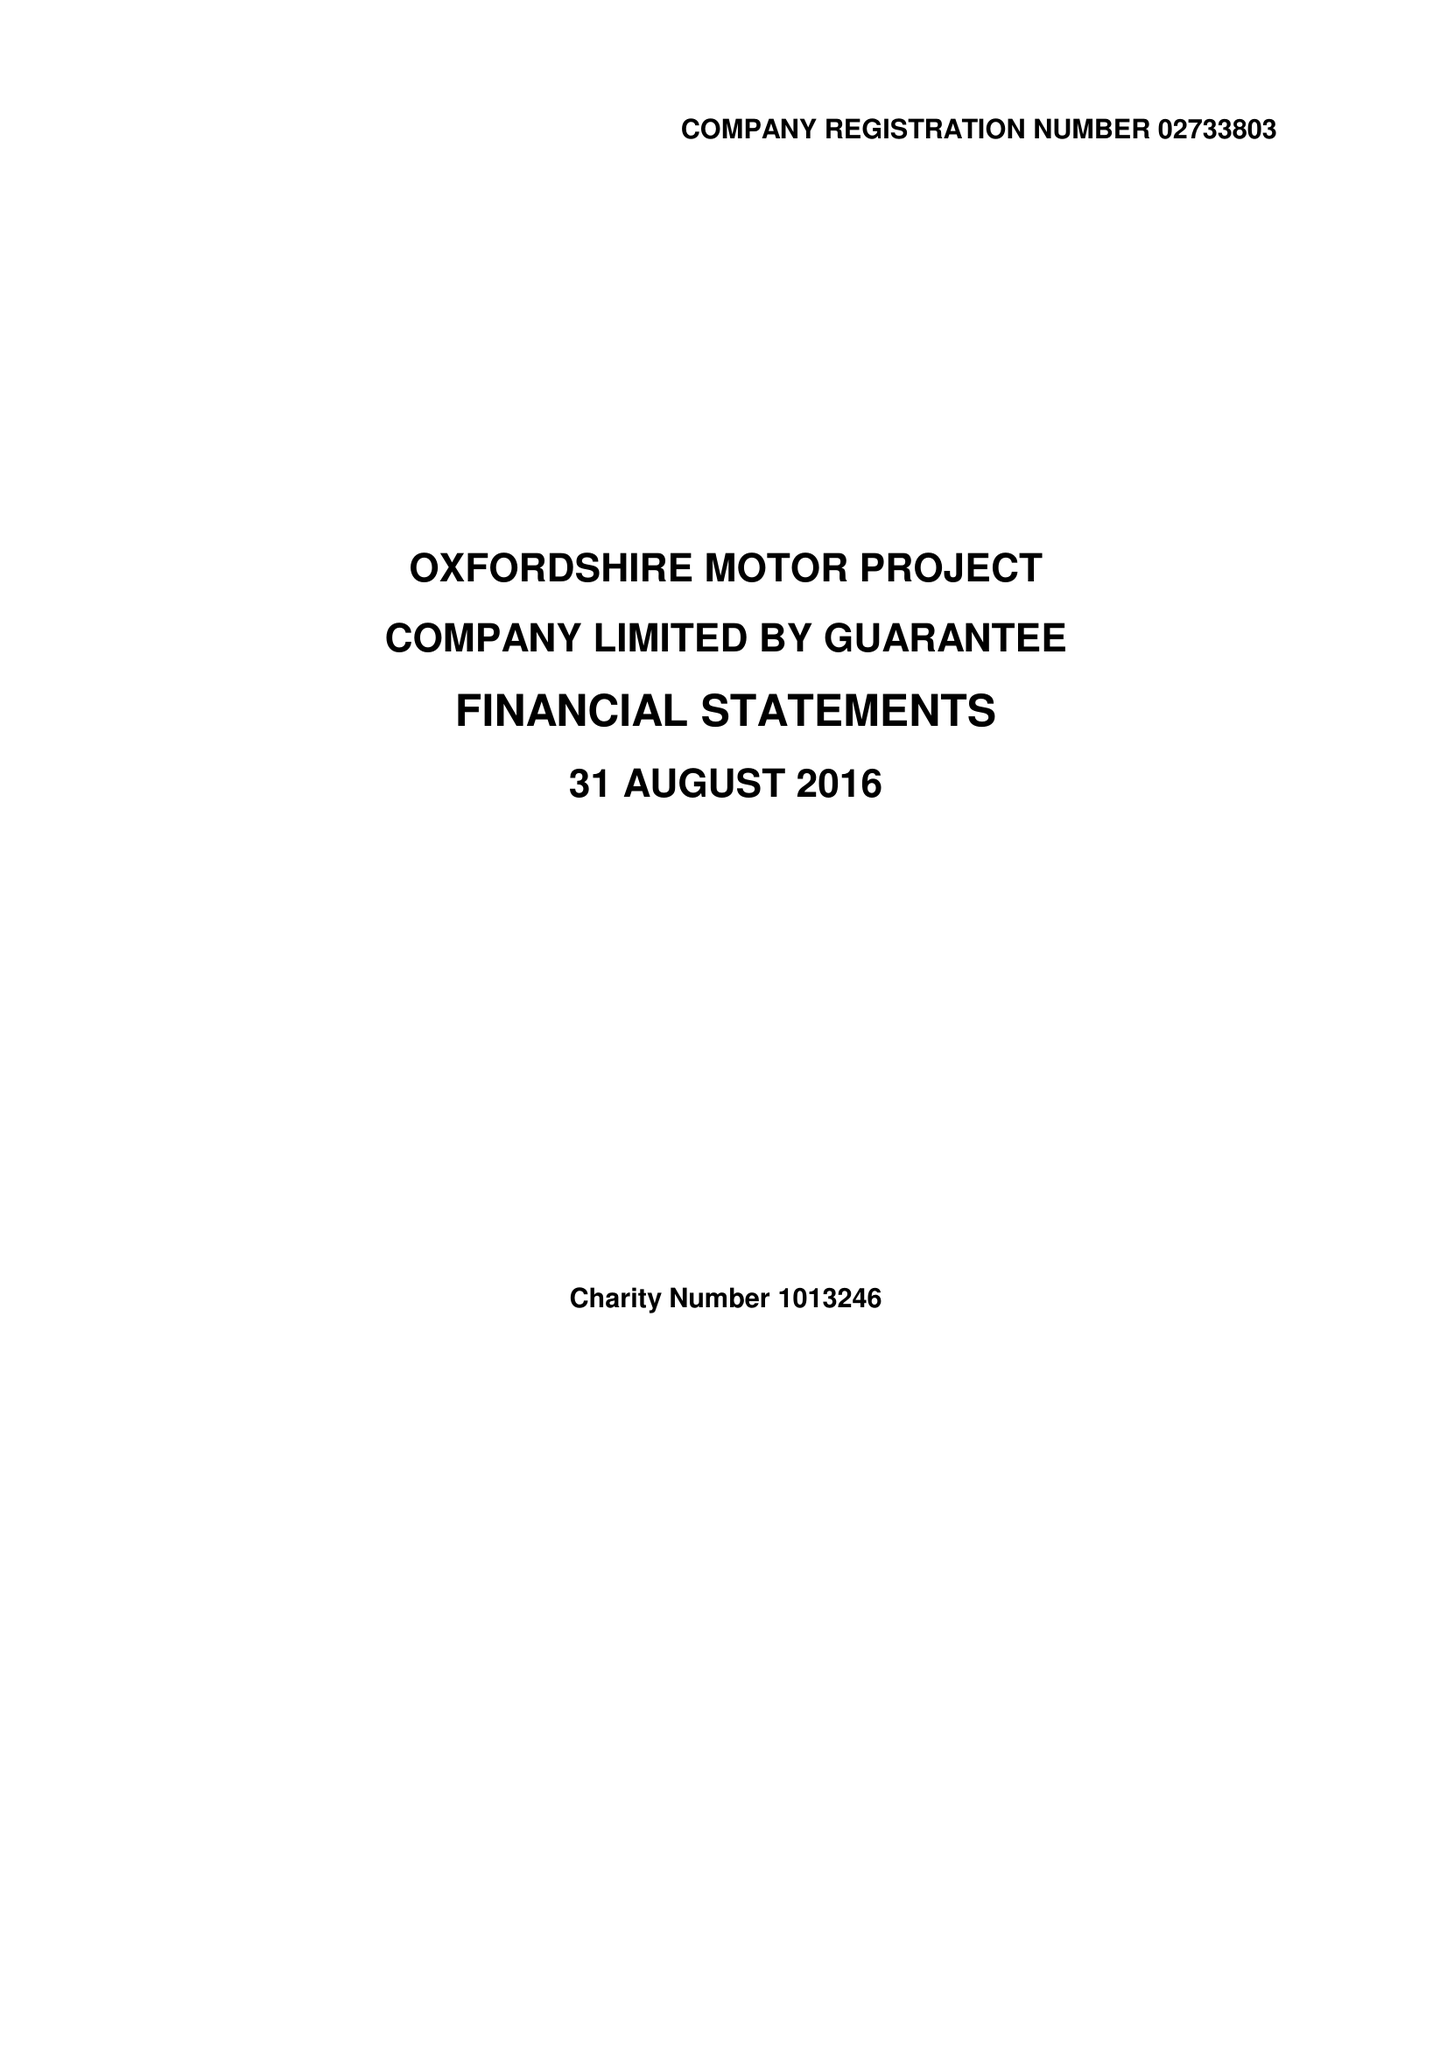What is the value for the income_annually_in_british_pounds?
Answer the question using a single word or phrase. 287926.00 